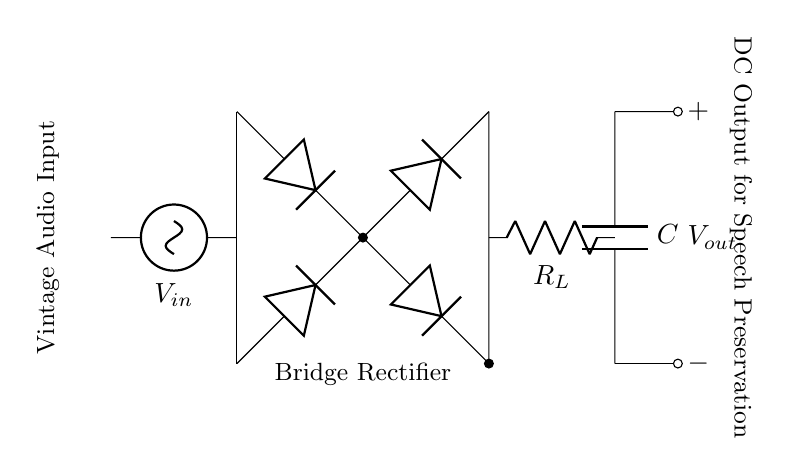What is the type of rectifier shown in the diagram? The circuit diagram shows a bridge rectifier, characterized by four diodes arranged in a bridge configuration to convert alternating current to direct current.
Answer: Bridge rectifier What is the purpose of the load resistor \( R_L \) in this circuit? The load resistor \( R_L \) dissipates the current supplied by the rectified output of the circuit, allowing it to drive connected components, in this case preserving audio signals.
Answer: To dissipate current What component is used to smooth the output voltage? The capacitor \( C \) is used to smooth the output voltage, reducing ripple by storing charge and releasing it when the voltage drops.
Answer: Capacitor What is the function of the diodes in this circuit? The diodes allow current to pass in only one direction, effectively blocking reverse voltage and enabling the conversion of AC input to DC output.
Answer: Allow current flow How many diodes are used in the bridge rectifier configuration? There are four diodes arranged in a bridge formation to provide full-wave rectification of the input AC signal.
Answer: Four What does \( V_{in} \) represent in this circuit? \( V_{in} \) represents the input alternating voltage, which is applied to the circuit for rectification into direct current.
Answer: Input voltage What would happen if one diode were removed from the bridge rectifier? If one diode were removed, the circuit would not be able to effectively convert the entire AC waveform to DC, resulting in incomplete rectification and loss of current in one half of the AC cycle.
Answer: Incomplete rectification 